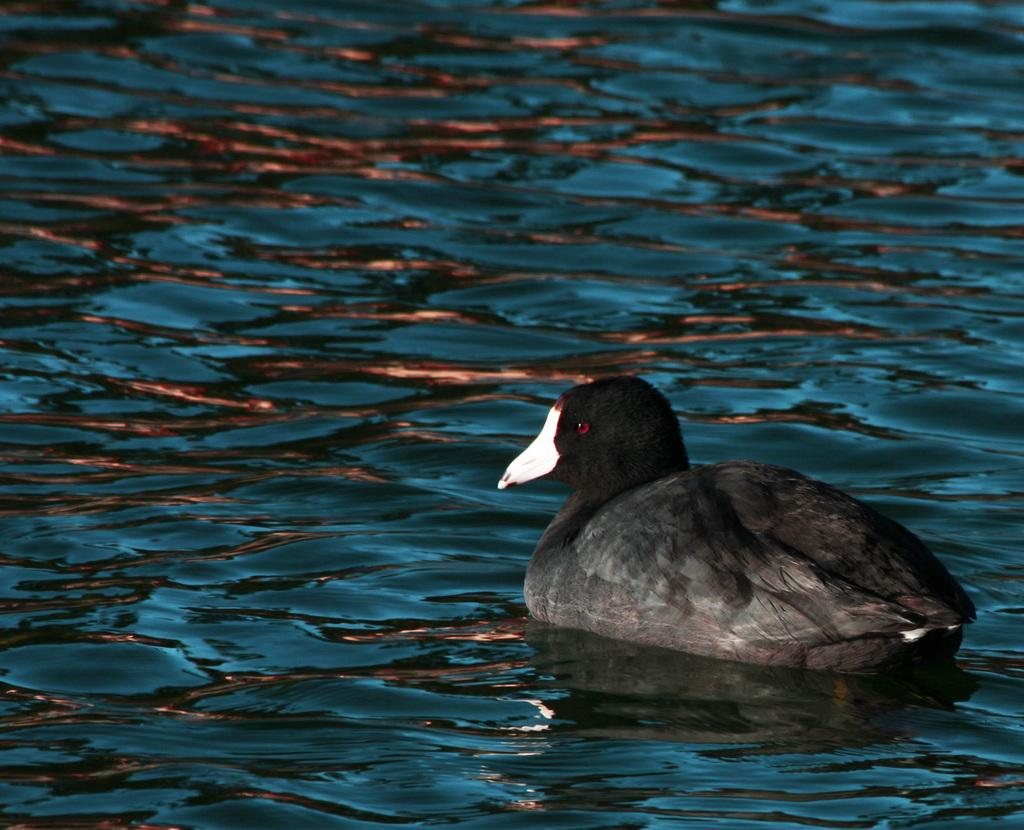What is present in the image? There is water in the image. Can you describe anything else in the image? There is a bird above the water in the image. What type of development is taking place near the water in the image? There is no indication of any development in the image; it only features water and a bird. Can you see any hooks in the image? There are no hooks present in the image. 